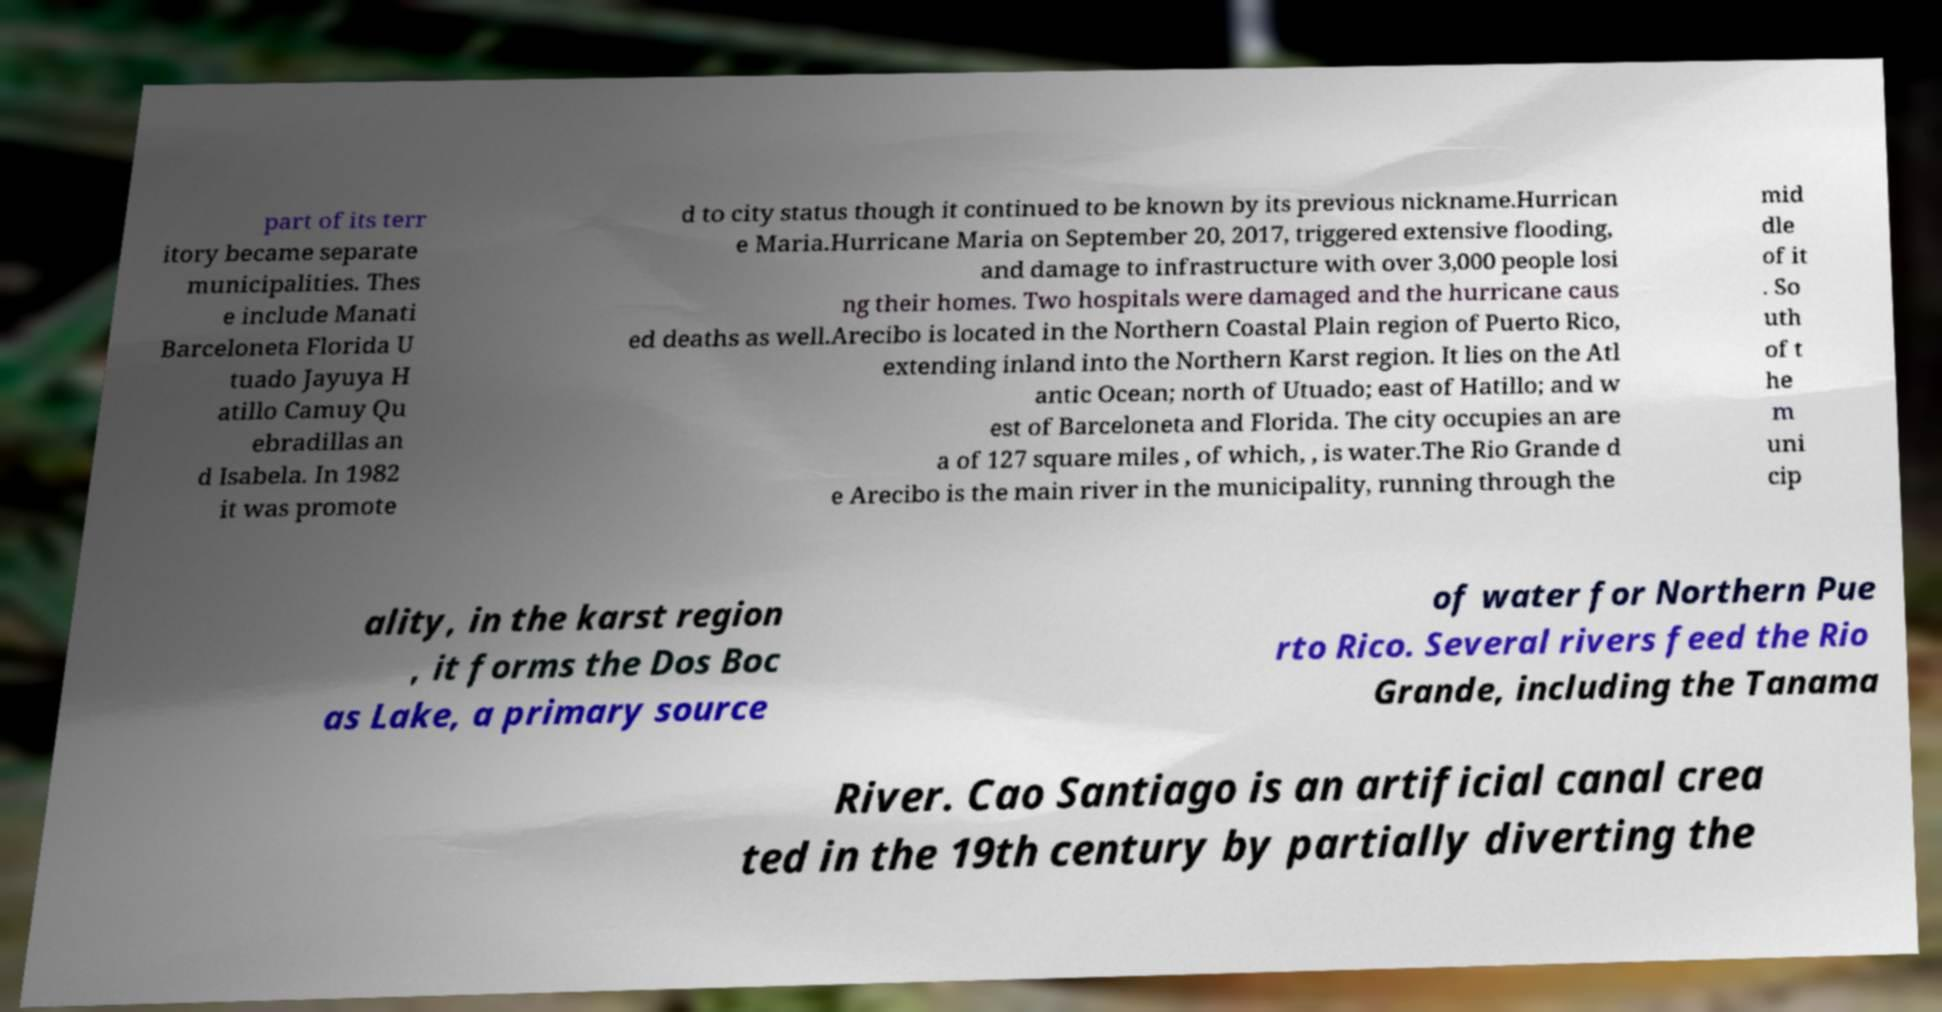For documentation purposes, I need the text within this image transcribed. Could you provide that? part of its terr itory became separate municipalities. Thes e include Manati Barceloneta Florida U tuado Jayuya H atillo Camuy Qu ebradillas an d Isabela. In 1982 it was promote d to city status though it continued to be known by its previous nickname.Hurrican e Maria.Hurricane Maria on September 20, 2017, triggered extensive flooding, and damage to infrastructure with over 3,000 people losi ng their homes. Two hospitals were damaged and the hurricane caus ed deaths as well.Arecibo is located in the Northern Coastal Plain region of Puerto Rico, extending inland into the Northern Karst region. It lies on the Atl antic Ocean; north of Utuado; east of Hatillo; and w est of Barceloneta and Florida. The city occupies an are a of 127 square miles , of which, , is water.The Rio Grande d e Arecibo is the main river in the municipality, running through the mid dle of it . So uth of t he m uni cip ality, in the karst region , it forms the Dos Boc as Lake, a primary source of water for Northern Pue rto Rico. Several rivers feed the Rio Grande, including the Tanama River. Cao Santiago is an artificial canal crea ted in the 19th century by partially diverting the 